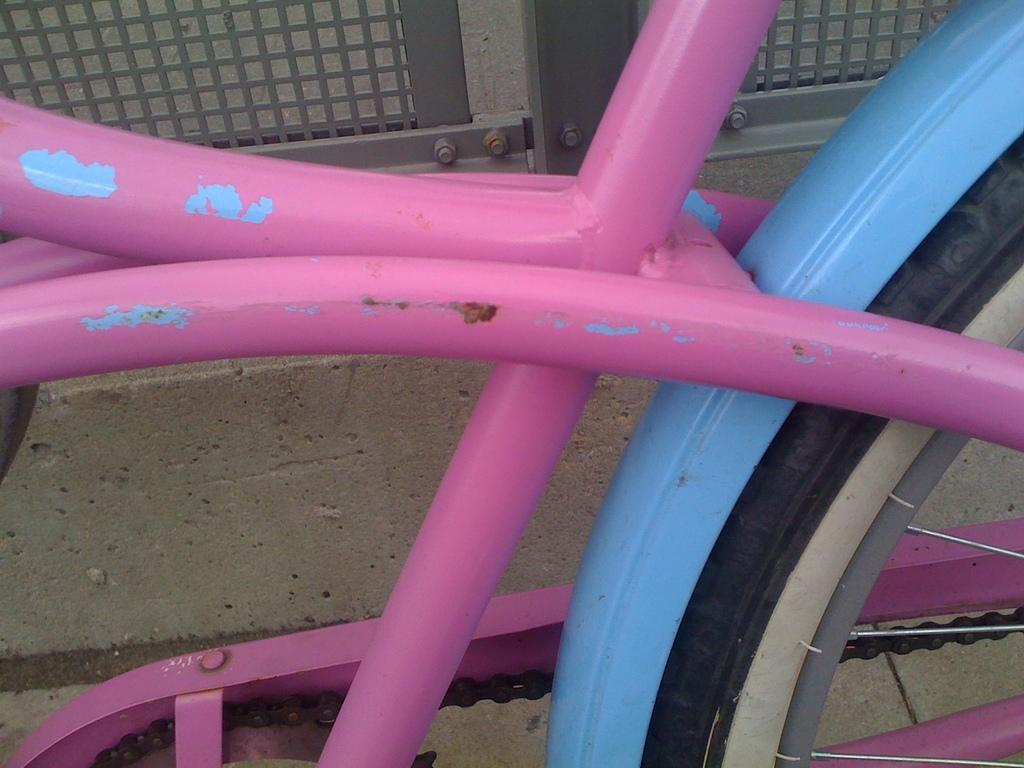What is the main object in the image? There is a bicycle in the image. What type of surface is visible in the image? There is ground visible in the image. What is the material of the fence in the image? The fence in the image is made of metal. What is the chance of the moon being visible in the image? The moon is not visible in the image, as it is not mentioned in the provided facts. 